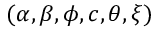<formula> <loc_0><loc_0><loc_500><loc_500>( \alpha , \beta , \phi , c , \theta , \xi )</formula> 